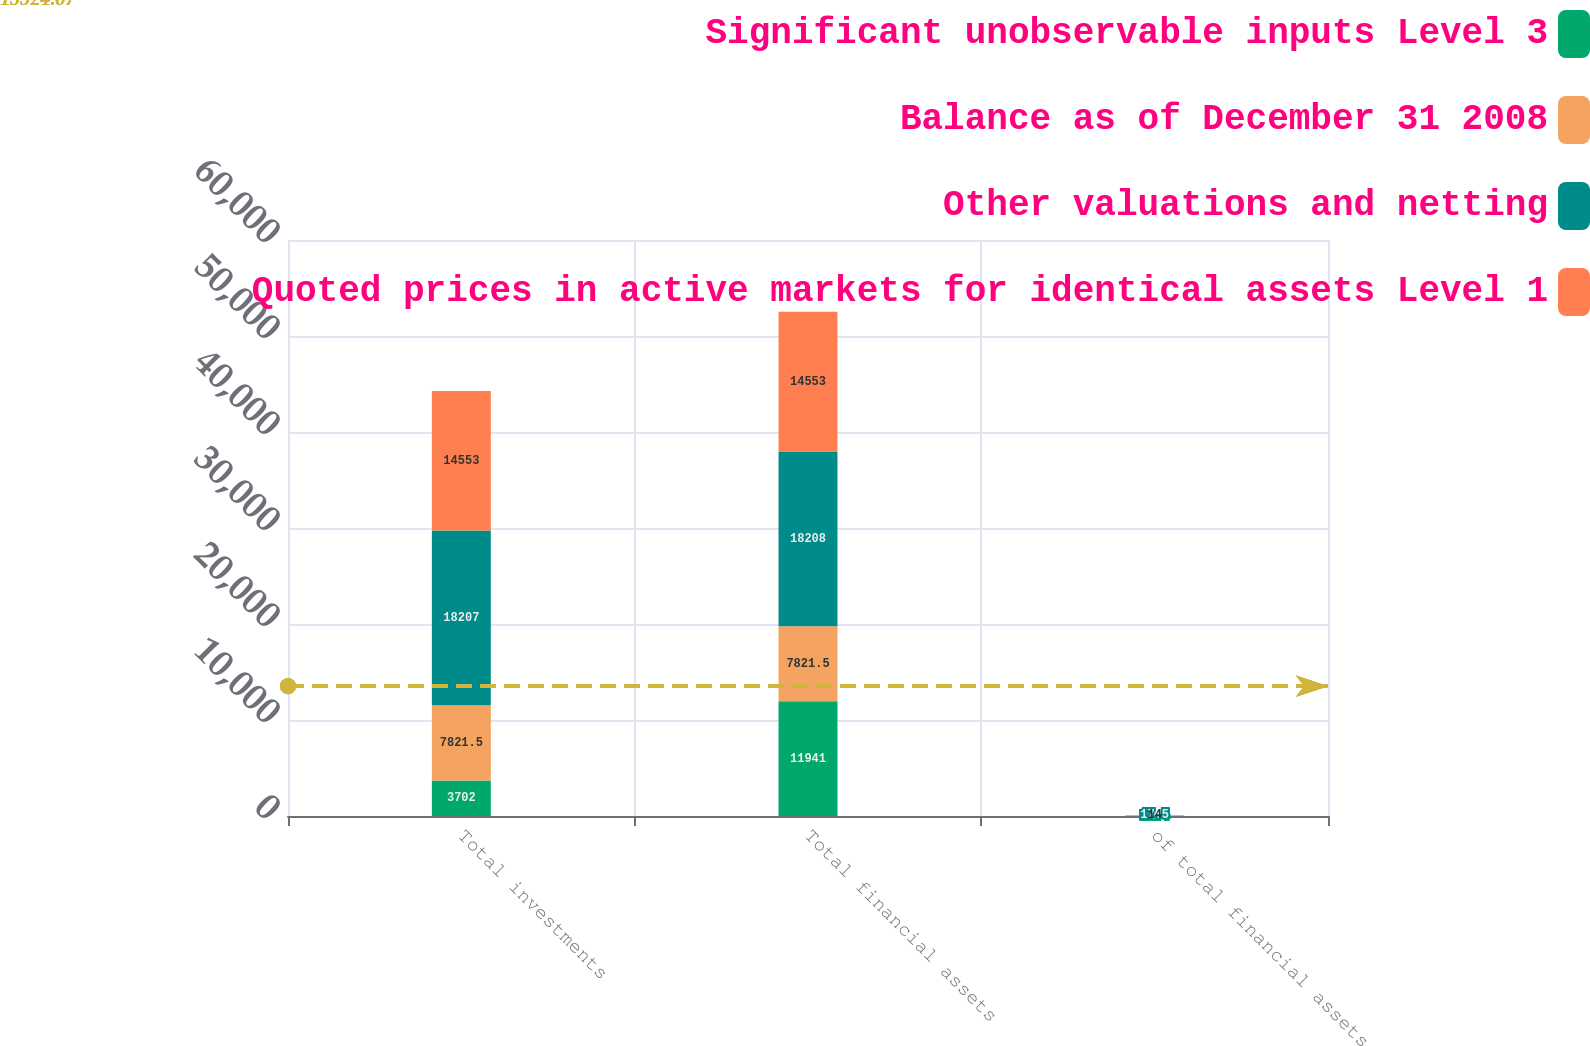Convert chart. <chart><loc_0><loc_0><loc_500><loc_500><stacked_bar_chart><ecel><fcel>Total investments<fcel>Total financial assets<fcel>of total financial assets<nl><fcel>Significant unobservable inputs Level 3<fcel>3702<fcel>11941<fcel>11.4<nl><fcel>Balance as of December 31 2008<fcel>7821.5<fcel>7821.5<fcel>57.1<nl><fcel>Other valuations and netting<fcel>18207<fcel>18208<fcel>17.5<nl><fcel>Quoted prices in active markets for identical assets Level 1<fcel>14553<fcel>14553<fcel>14<nl></chart> 